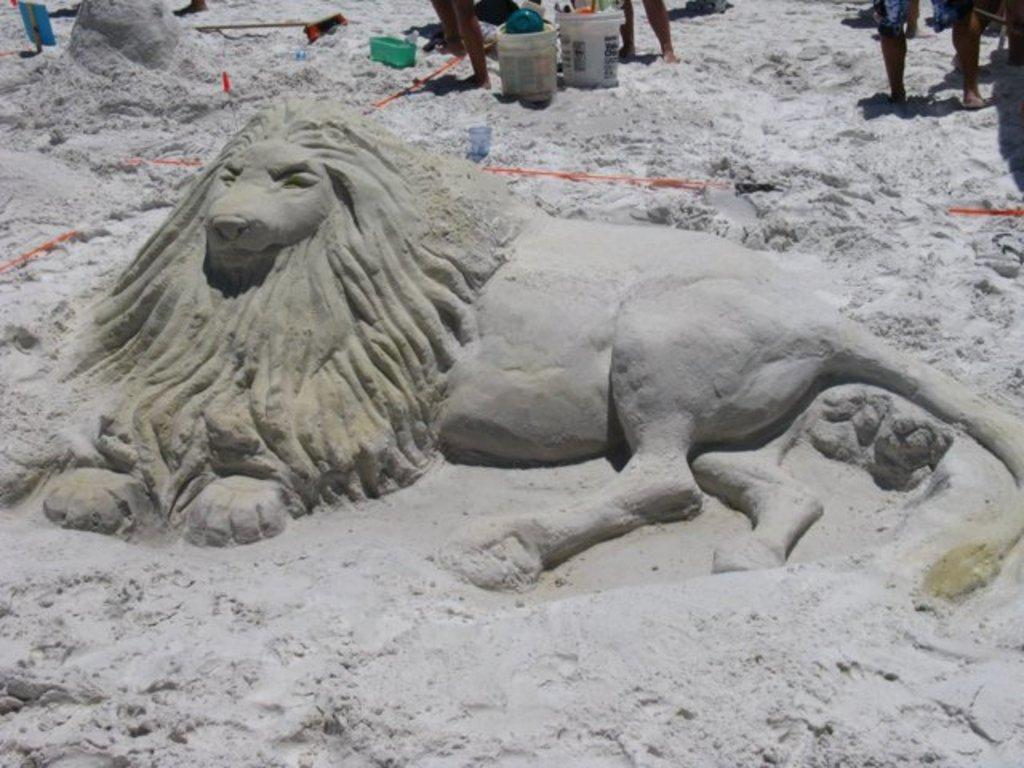What is the main subject of the image? There is a sand sculpture in the image. What can be seen at the top of the image? Containers, sticks, and objects are present at the top of the image. What is the purpose of the sticks in the image? The sticks may be used as tools for creating or maintaining the sand sculpture. Are there any people in the image? Yes, people are standing in the image. What type of loaf is being cut by the scissors in the image? There are no loaves or scissors present in the image; it features a sand sculpture and related objects. 